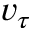<formula> <loc_0><loc_0><loc_500><loc_500>v _ { \tau }</formula> 